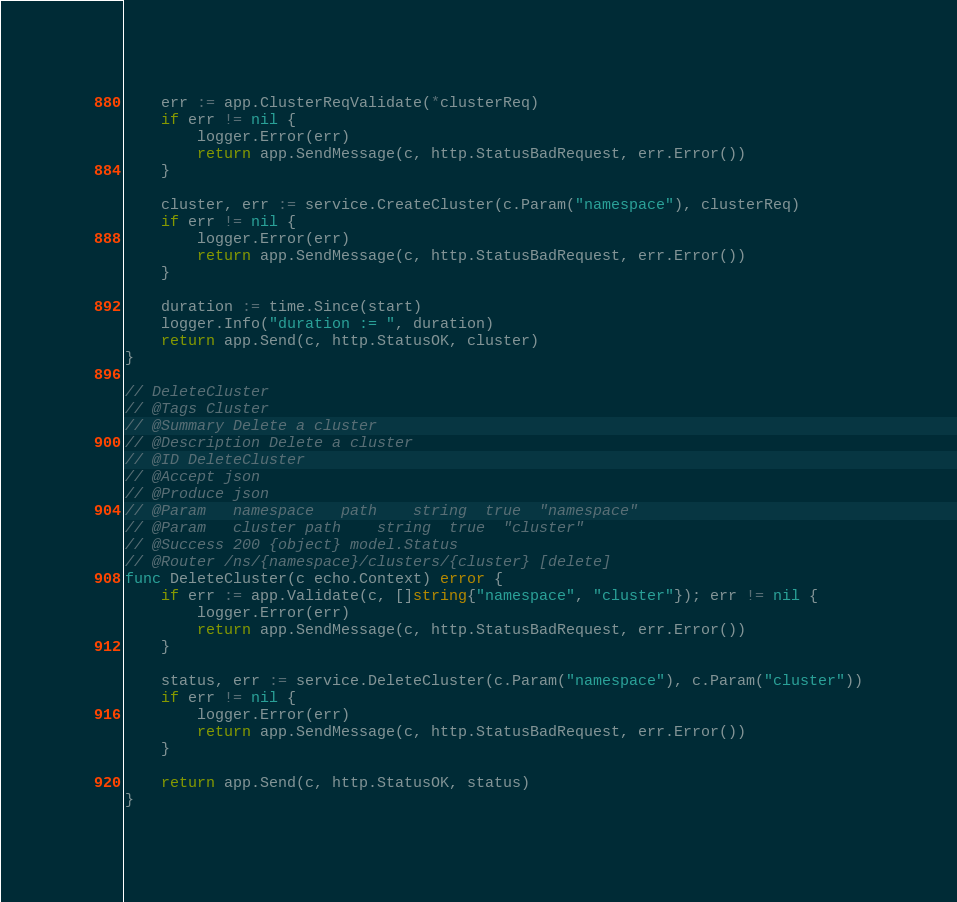<code> <loc_0><loc_0><loc_500><loc_500><_Go_>
	err := app.ClusterReqValidate(*clusterReq)
	if err != nil {
		logger.Error(err)
		return app.SendMessage(c, http.StatusBadRequest, err.Error())
	}

	cluster, err := service.CreateCluster(c.Param("namespace"), clusterReq)
	if err != nil {
		logger.Error(err)
		return app.SendMessage(c, http.StatusBadRequest, err.Error())
	}

	duration := time.Since(start)
	logger.Info("duration := ", duration)
	return app.Send(c, http.StatusOK, cluster)
}

// DeleteCluster
// @Tags Cluster
// @Summary Delete a cluster
// @Description Delete a cluster
// @ID DeleteCluster
// @Accept json
// @Produce json
// @Param	namespace	path	string	true  "namespace"
// @Param	cluster	path	string	true  "cluster"
// @Success 200 {object} model.Status
// @Router /ns/{namespace}/clusters/{cluster} [delete]
func DeleteCluster(c echo.Context) error {
	if err := app.Validate(c, []string{"namespace", "cluster"}); err != nil {
		logger.Error(err)
		return app.SendMessage(c, http.StatusBadRequest, err.Error())
	}

	status, err := service.DeleteCluster(c.Param("namespace"), c.Param("cluster"))
	if err != nil {
		logger.Error(err)
		return app.SendMessage(c, http.StatusBadRequest, err.Error())
	}

	return app.Send(c, http.StatusOK, status)
}
</code> 